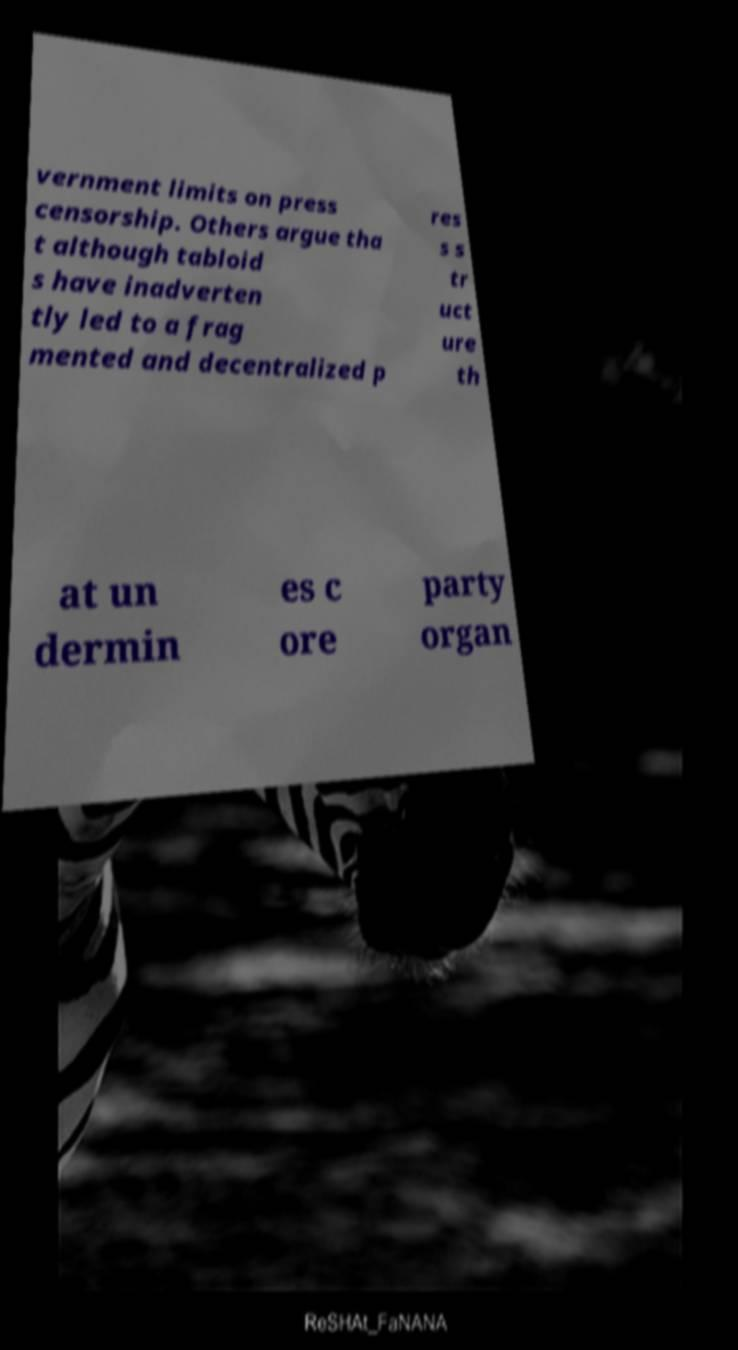For documentation purposes, I need the text within this image transcribed. Could you provide that? vernment limits on press censorship. Others argue tha t although tabloid s have inadverten tly led to a frag mented and decentralized p res s s tr uct ure th at un dermin es c ore party organ 